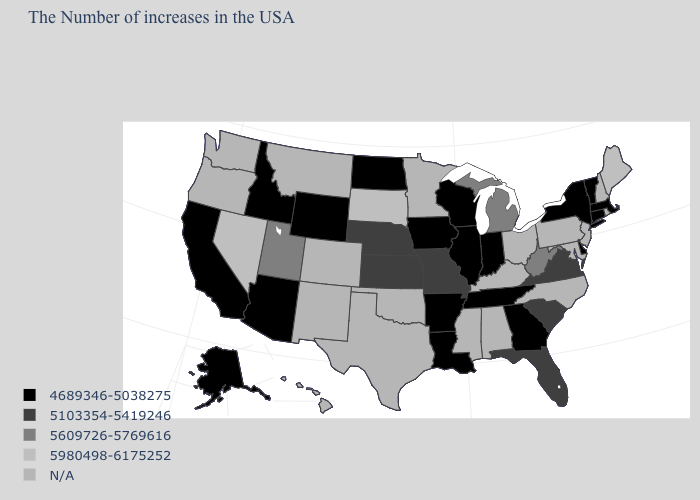Which states hav the highest value in the West?
Give a very brief answer. Nevada. Name the states that have a value in the range 5103354-5419246?
Write a very short answer. Virginia, South Carolina, Florida, Missouri, Kansas, Nebraska. How many symbols are there in the legend?
Write a very short answer. 5. What is the value of Alabama?
Write a very short answer. N/A. Name the states that have a value in the range N/A?
Quick response, please. Rhode Island, New Hampshire, New Jersey, Maryland, Pennsylvania, North Carolina, Ohio, Kentucky, Alabama, Mississippi, Minnesota, Oklahoma, Texas, Colorado, New Mexico, Montana, Washington, Oregon, Hawaii. Does Massachusetts have the highest value in the Northeast?
Keep it brief. No. Among the states that border Montana , does North Dakota have the lowest value?
Write a very short answer. Yes. Name the states that have a value in the range N/A?
Short answer required. Rhode Island, New Hampshire, New Jersey, Maryland, Pennsylvania, North Carolina, Ohio, Kentucky, Alabama, Mississippi, Minnesota, Oklahoma, Texas, Colorado, New Mexico, Montana, Washington, Oregon, Hawaii. Which states have the lowest value in the USA?
Be succinct. Massachusetts, Vermont, Connecticut, New York, Delaware, Georgia, Indiana, Tennessee, Wisconsin, Illinois, Louisiana, Arkansas, Iowa, North Dakota, Wyoming, Arizona, Idaho, California, Alaska. What is the value of West Virginia?
Keep it brief. 5609726-5769616. Name the states that have a value in the range N/A?
Keep it brief. Rhode Island, New Hampshire, New Jersey, Maryland, Pennsylvania, North Carolina, Ohio, Kentucky, Alabama, Mississippi, Minnesota, Oklahoma, Texas, Colorado, New Mexico, Montana, Washington, Oregon, Hawaii. Does the first symbol in the legend represent the smallest category?
Concise answer only. Yes. 